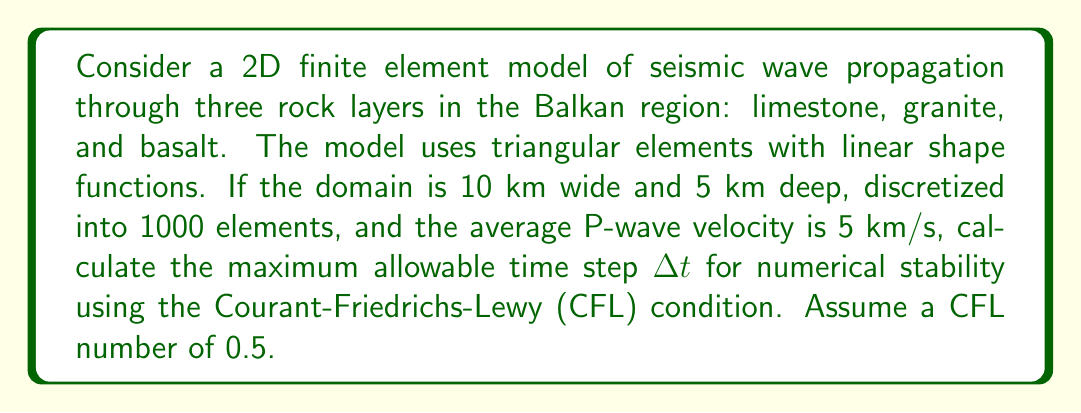Provide a solution to this math problem. To solve this problem, we'll follow these steps:

1) First, we need to determine the characteristic element size. Given that we have 1000 elements in a 10 km × 5 km domain:

   Area of domain = 10 km × 5 km = 50 km²
   Area per element ≈ 50 km² / 1000 = 0.05 km²

   Assuming equilateral triangles, the side length $h$ of each element is:

   $$h = \sqrt{\frac{4}{\sqrt{3}} \times 0.05} \approx 0.274 \text{ km}$$

2) The CFL condition for wave propagation problems is given by:

   $$\Delta t \leq C \frac{h}{v}$$

   Where:
   - $\Delta t$ is the time step
   - $C$ is the CFL number (given as 0.5)
   - $h$ is the characteristic element size
   - $v$ is the wave velocity

3) Substituting the values:

   $$\Delta t \leq 0.5 \times \frac{0.274 \text{ km}}{5 \text{ km/s}}$$

4) Solving for $\Delta t$:

   $$\Delta t \leq 0.0274 \text{ s}$$

Therefore, the maximum allowable time step for numerical stability is 0.0274 seconds.
Answer: 0.0274 s 